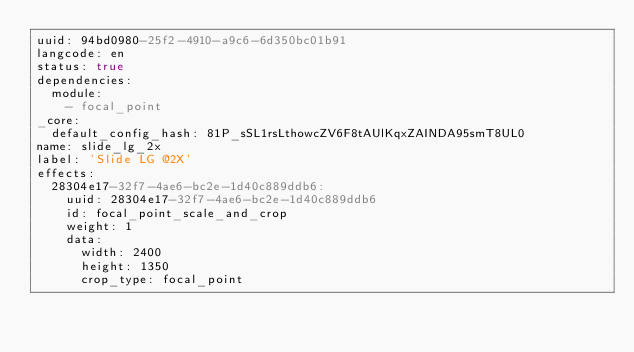<code> <loc_0><loc_0><loc_500><loc_500><_YAML_>uuid: 94bd0980-25f2-4910-a9c6-6d350bc01b91
langcode: en
status: true
dependencies:
  module:
    - focal_point
_core:
  default_config_hash: 81P_sSL1rsLthowcZV6F8tAUlKqxZAINDA95smT8UL0
name: slide_lg_2x
label: 'Slide LG @2X'
effects:
  28304e17-32f7-4ae6-bc2e-1d40c889ddb6:
    uuid: 28304e17-32f7-4ae6-bc2e-1d40c889ddb6
    id: focal_point_scale_and_crop
    weight: 1
    data:
      width: 2400
      height: 1350
      crop_type: focal_point
</code> 